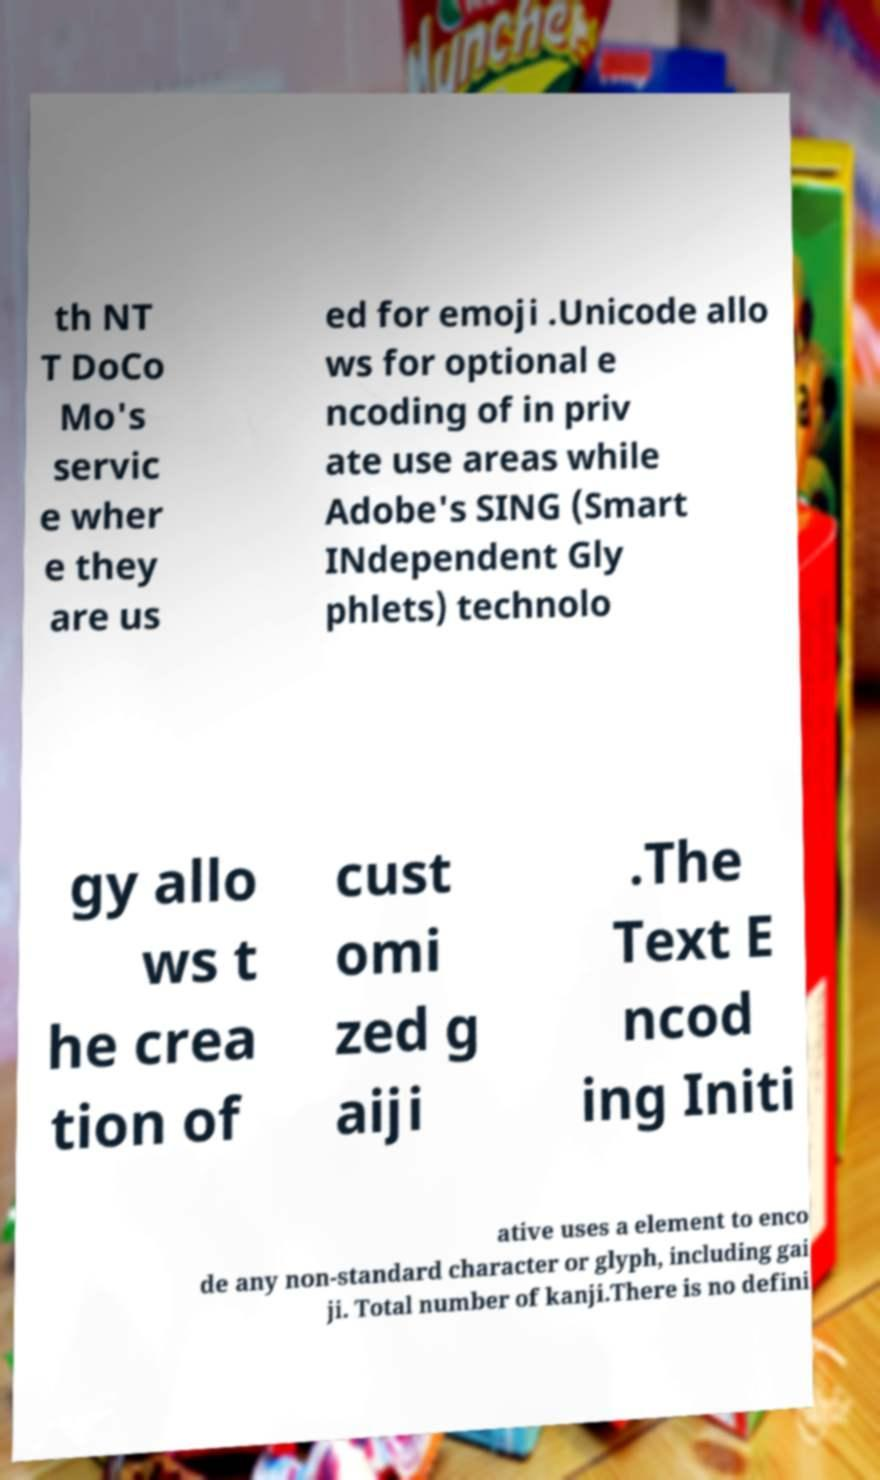For documentation purposes, I need the text within this image transcribed. Could you provide that? th NT T DoCo Mo's servic e wher e they are us ed for emoji .Unicode allo ws for optional e ncoding of in priv ate use areas while Adobe's SING (Smart INdependent Gly phlets) technolo gy allo ws t he crea tion of cust omi zed g aiji .The Text E ncod ing Initi ative uses a element to enco de any non-standard character or glyph, including gai ji. Total number of kanji.There is no defini 